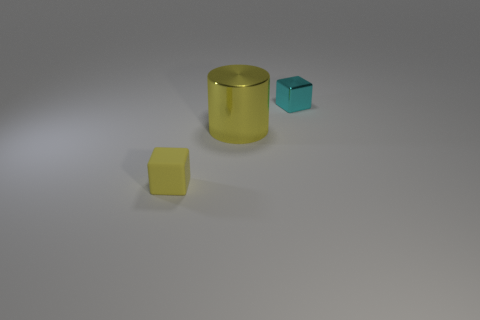Is there anything else that has the same size as the yellow cylinder?
Keep it short and to the point. No. There is a yellow cylinder that is the same material as the tiny cyan object; what is its size?
Keep it short and to the point. Large. What number of metallic things are either big yellow cylinders or tiny cyan blocks?
Your answer should be very brief. 2. The cyan thing is what size?
Provide a short and direct response. Small. Do the cyan thing and the metal cylinder have the same size?
Make the answer very short. No. There is a tiny thing that is on the right side of the small yellow block; what is it made of?
Give a very brief answer. Metal. There is another tiny object that is the same shape as the cyan thing; what is it made of?
Your answer should be compact. Rubber. There is a yellow object that is on the right side of the tiny rubber object; is there a object in front of it?
Your answer should be very brief. Yes. Do the tiny cyan thing and the yellow rubber object have the same shape?
Offer a very short reply. Yes. What is the shape of the yellow thing that is the same material as the cyan cube?
Your answer should be very brief. Cylinder. 